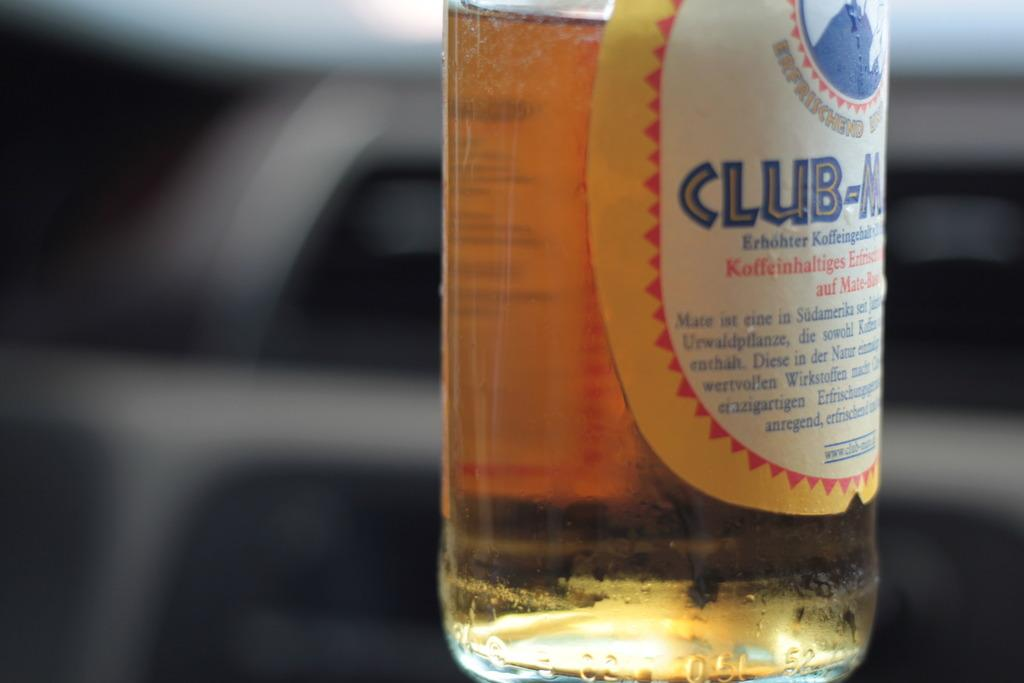Provide a one-sentence caption for the provided image. A bottle with the word club on it in blue is half full. 